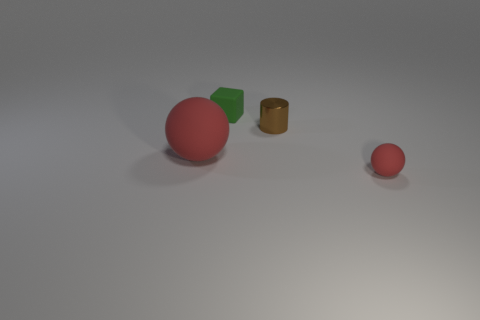There is a brown thing behind the small rubber thing that is in front of the red sphere that is to the left of the cylinder; what is its size?
Keep it short and to the point. Small. How big is the matte object that is both in front of the small green object and behind the tiny ball?
Offer a very short reply. Large. There is a thing to the left of the object behind the tiny brown cylinder; what is its shape?
Make the answer very short. Sphere. Is there anything else that is the same color as the small shiny cylinder?
Ensure brevity in your answer.  No. The rubber object that is on the right side of the green object has what shape?
Your answer should be very brief. Sphere. What is the shape of the matte object that is on the left side of the small matte ball and in front of the tiny green matte cube?
Provide a short and direct response. Sphere. What number of red things are either rubber objects or large rubber objects?
Offer a terse response. 2. There is a small object in front of the large red matte object; does it have the same color as the large object?
Provide a succinct answer. Yes. There is a block to the right of the rubber object on the left side of the green rubber cube; what is its size?
Offer a very short reply. Small. There is a red thing that is the same size as the brown metallic cylinder; what material is it?
Your answer should be very brief. Rubber. 